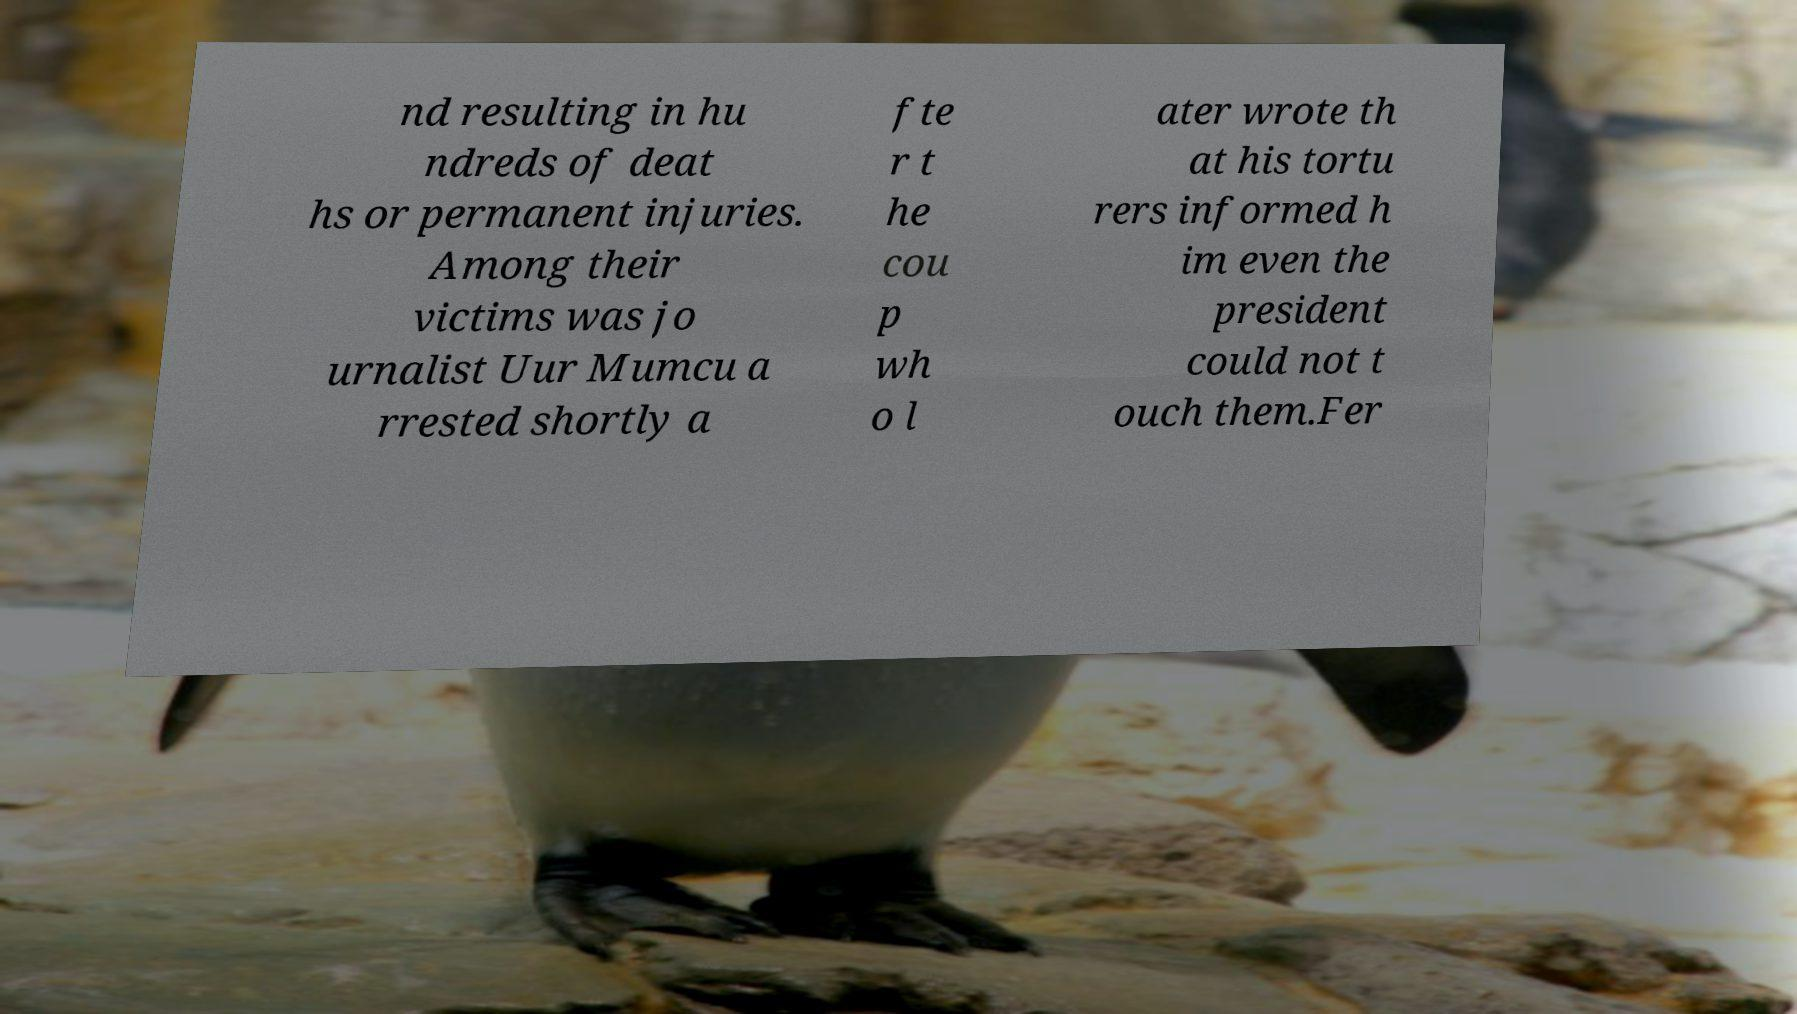I need the written content from this picture converted into text. Can you do that? nd resulting in hu ndreds of deat hs or permanent injuries. Among their victims was jo urnalist Uur Mumcu a rrested shortly a fte r t he cou p wh o l ater wrote th at his tortu rers informed h im even the president could not t ouch them.Fer 